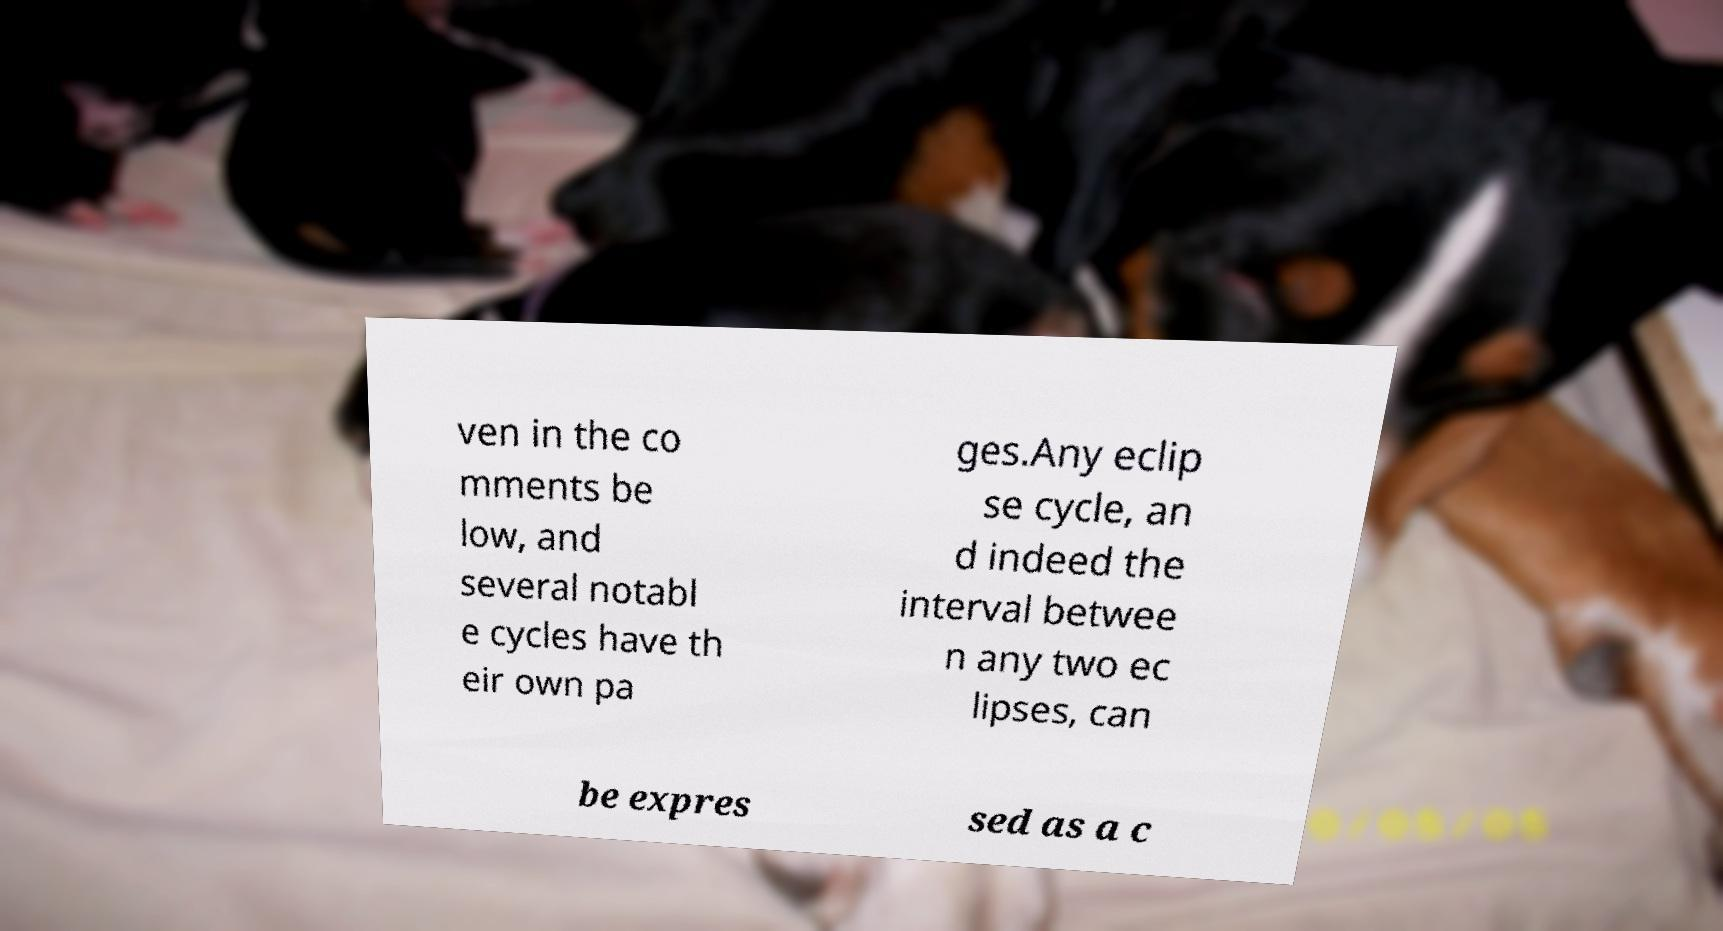Can you accurately transcribe the text from the provided image for me? ven in the co mments be low, and several notabl e cycles have th eir own pa ges.Any eclip se cycle, an d indeed the interval betwee n any two ec lipses, can be expres sed as a c 